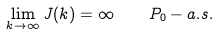Convert formula to latex. <formula><loc_0><loc_0><loc_500><loc_500>\lim _ { k \rightarrow \infty } J ( k ) = \infty \quad P _ { 0 } - a . s .</formula> 